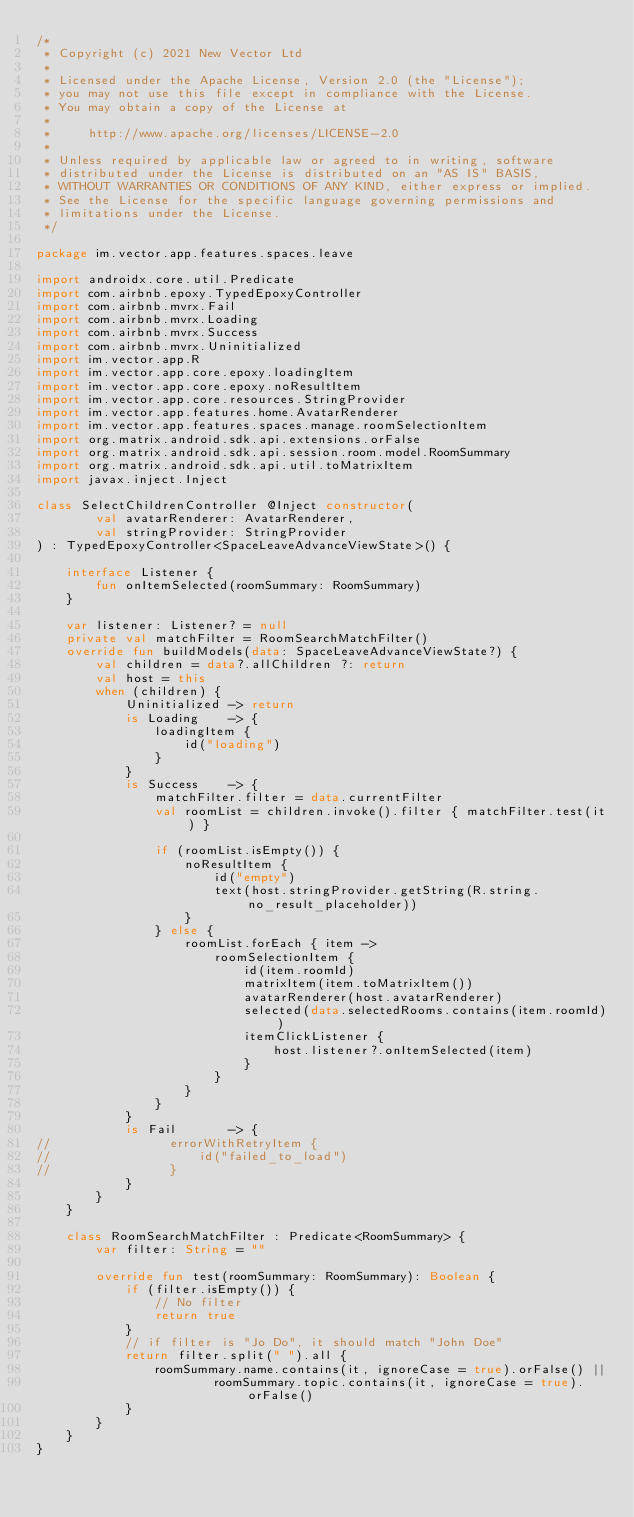<code> <loc_0><loc_0><loc_500><loc_500><_Kotlin_>/*
 * Copyright (c) 2021 New Vector Ltd
 *
 * Licensed under the Apache License, Version 2.0 (the "License");
 * you may not use this file except in compliance with the License.
 * You may obtain a copy of the License at
 *
 *     http://www.apache.org/licenses/LICENSE-2.0
 *
 * Unless required by applicable law or agreed to in writing, software
 * distributed under the License is distributed on an "AS IS" BASIS,
 * WITHOUT WARRANTIES OR CONDITIONS OF ANY KIND, either express or implied.
 * See the License for the specific language governing permissions and
 * limitations under the License.
 */

package im.vector.app.features.spaces.leave

import androidx.core.util.Predicate
import com.airbnb.epoxy.TypedEpoxyController
import com.airbnb.mvrx.Fail
import com.airbnb.mvrx.Loading
import com.airbnb.mvrx.Success
import com.airbnb.mvrx.Uninitialized
import im.vector.app.R
import im.vector.app.core.epoxy.loadingItem
import im.vector.app.core.epoxy.noResultItem
import im.vector.app.core.resources.StringProvider
import im.vector.app.features.home.AvatarRenderer
import im.vector.app.features.spaces.manage.roomSelectionItem
import org.matrix.android.sdk.api.extensions.orFalse
import org.matrix.android.sdk.api.session.room.model.RoomSummary
import org.matrix.android.sdk.api.util.toMatrixItem
import javax.inject.Inject

class SelectChildrenController @Inject constructor(
        val avatarRenderer: AvatarRenderer,
        val stringProvider: StringProvider
) : TypedEpoxyController<SpaceLeaveAdvanceViewState>() {

    interface Listener {
        fun onItemSelected(roomSummary: RoomSummary)
    }

    var listener: Listener? = null
    private val matchFilter = RoomSearchMatchFilter()
    override fun buildModels(data: SpaceLeaveAdvanceViewState?) {
        val children = data?.allChildren ?: return
        val host = this
        when (children) {
            Uninitialized -> return
            is Loading    -> {
                loadingItem {
                    id("loading")
                }
            }
            is Success    -> {
                matchFilter.filter = data.currentFilter
                val roomList = children.invoke().filter { matchFilter.test(it) }

                if (roomList.isEmpty()) {
                    noResultItem {
                        id("empty")
                        text(host.stringProvider.getString(R.string.no_result_placeholder))
                    }
                } else {
                    roomList.forEach { item ->
                        roomSelectionItem {
                            id(item.roomId)
                            matrixItem(item.toMatrixItem())
                            avatarRenderer(host.avatarRenderer)
                            selected(data.selectedRooms.contains(item.roomId))
                            itemClickListener {
                                host.listener?.onItemSelected(item)
                            }
                        }
                    }
                }
            }
            is Fail       -> {
//                errorWithRetryItem {
//                    id("failed_to_load")
//                }
            }
        }
    }

    class RoomSearchMatchFilter : Predicate<RoomSummary> {
        var filter: String = ""

        override fun test(roomSummary: RoomSummary): Boolean {
            if (filter.isEmpty()) {
                // No filter
                return true
            }
            // if filter is "Jo Do", it should match "John Doe"
            return filter.split(" ").all {
                roomSummary.name.contains(it, ignoreCase = true).orFalse() ||
                        roomSummary.topic.contains(it, ignoreCase = true).orFalse()
            }
        }
    }
}
</code> 